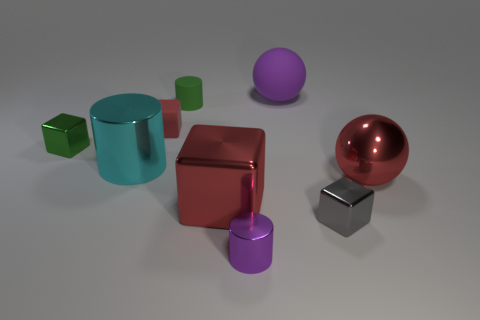Subtract all tiny green metallic cubes. How many cubes are left? 3 Subtract all cylinders. How many objects are left? 6 Subtract all large cyan spheres. Subtract all metal spheres. How many objects are left? 8 Add 6 large metal balls. How many large metal balls are left? 7 Add 9 purple spheres. How many purple spheres exist? 10 Subtract all purple balls. How many balls are left? 1 Subtract 0 purple cubes. How many objects are left? 9 Subtract 1 balls. How many balls are left? 1 Subtract all green spheres. Subtract all gray blocks. How many spheres are left? 2 Subtract all brown blocks. How many yellow balls are left? 0 